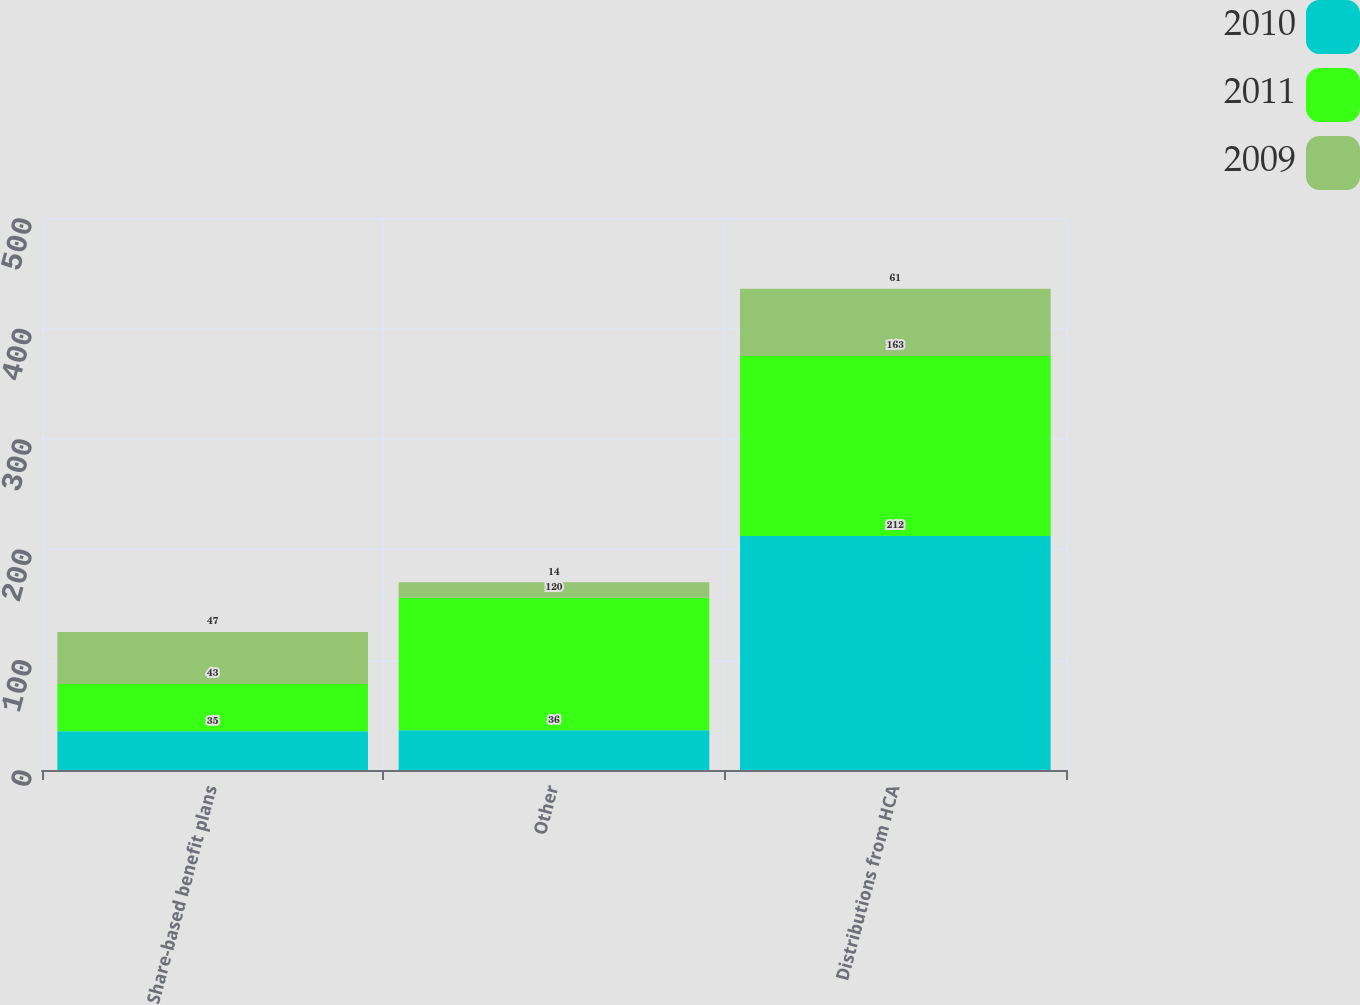Convert chart. <chart><loc_0><loc_0><loc_500><loc_500><stacked_bar_chart><ecel><fcel>Share-based benefit plans<fcel>Other<fcel>Distributions from HCA<nl><fcel>2010<fcel>35<fcel>36<fcel>212<nl><fcel>2011<fcel>43<fcel>120<fcel>163<nl><fcel>2009<fcel>47<fcel>14<fcel>61<nl></chart> 